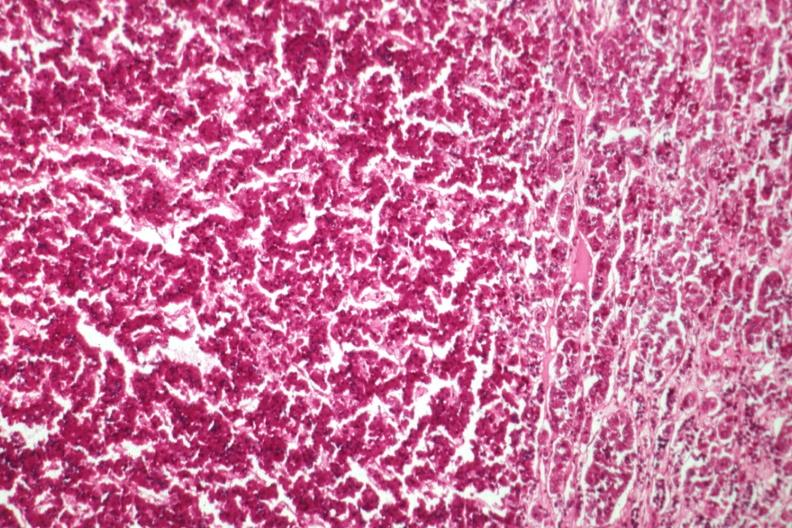s abdomen present?
Answer the question using a single word or phrase. No 